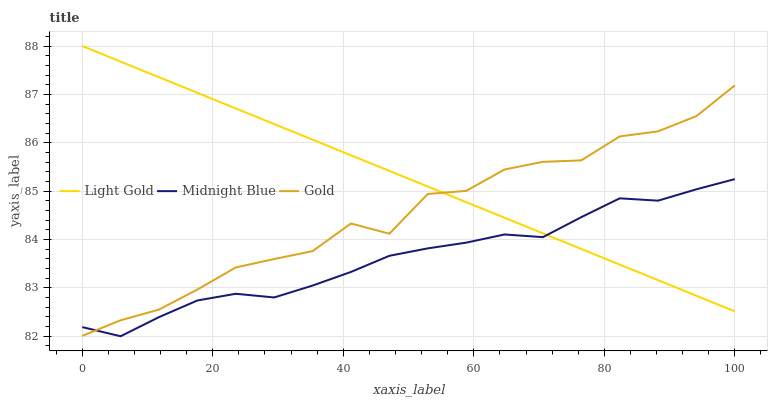Does Midnight Blue have the minimum area under the curve?
Answer yes or no. Yes. Does Light Gold have the maximum area under the curve?
Answer yes or no. Yes. Does Gold have the minimum area under the curve?
Answer yes or no. No. Does Gold have the maximum area under the curve?
Answer yes or no. No. Is Light Gold the smoothest?
Answer yes or no. Yes. Is Gold the roughest?
Answer yes or no. Yes. Is Midnight Blue the smoothest?
Answer yes or no. No. Is Midnight Blue the roughest?
Answer yes or no. No. Does Gold have the lowest value?
Answer yes or no. No. Does Light Gold have the highest value?
Answer yes or no. Yes. Does Gold have the highest value?
Answer yes or no. No. 